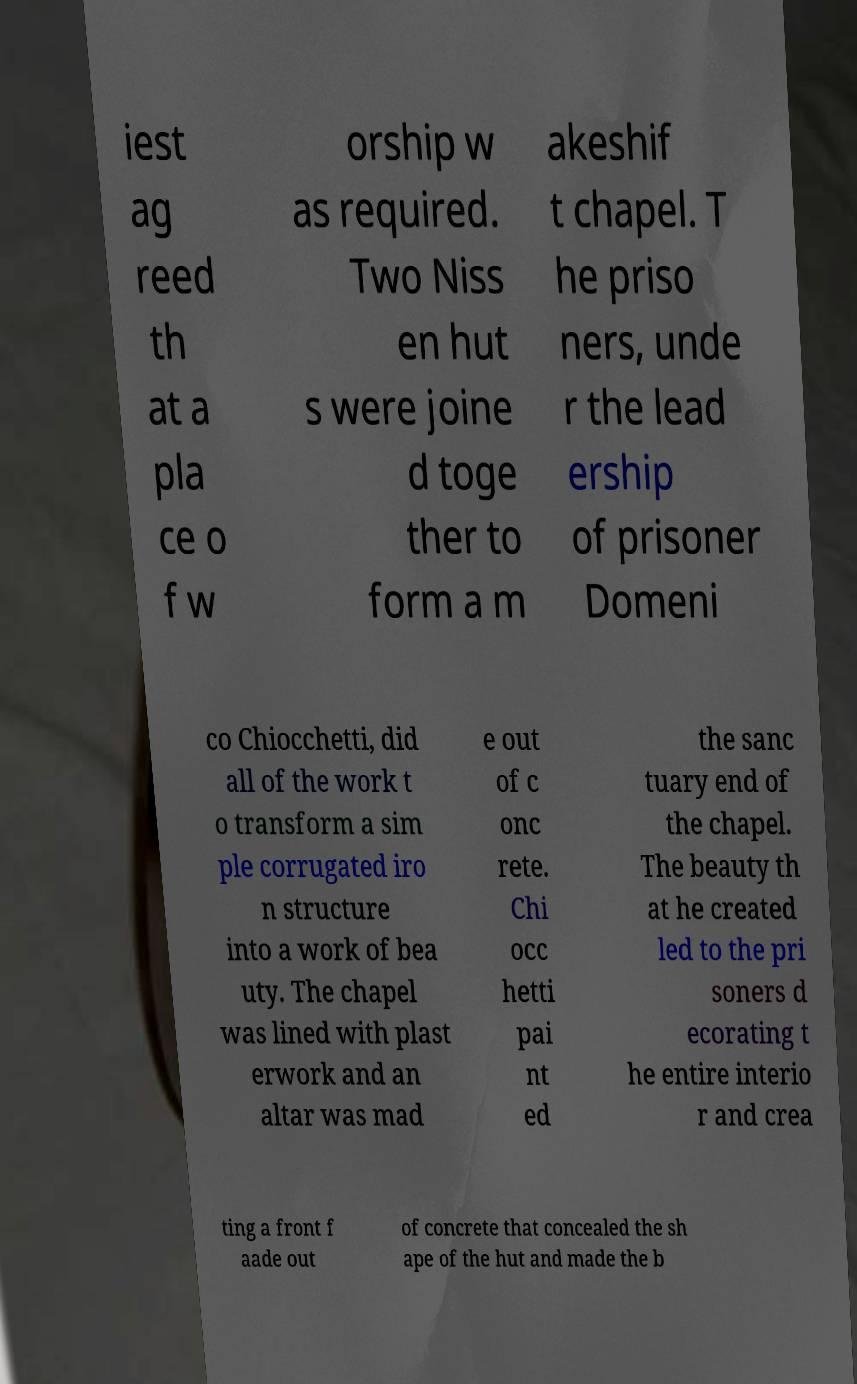I need the written content from this picture converted into text. Can you do that? iest ag reed th at a pla ce o f w orship w as required. Two Niss en hut s were joine d toge ther to form a m akeshif t chapel. T he priso ners, unde r the lead ership of prisoner Domeni co Chiocchetti, did all of the work t o transform a sim ple corrugated iro n structure into a work of bea uty. The chapel was lined with plast erwork and an altar was mad e out of c onc rete. Chi occ hetti pai nt ed the sanc tuary end of the chapel. The beauty th at he created led to the pri soners d ecorating t he entire interio r and crea ting a front f aade out of concrete that concealed the sh ape of the hut and made the b 